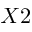Convert formula to latex. <formula><loc_0><loc_0><loc_500><loc_500>X 2</formula> 